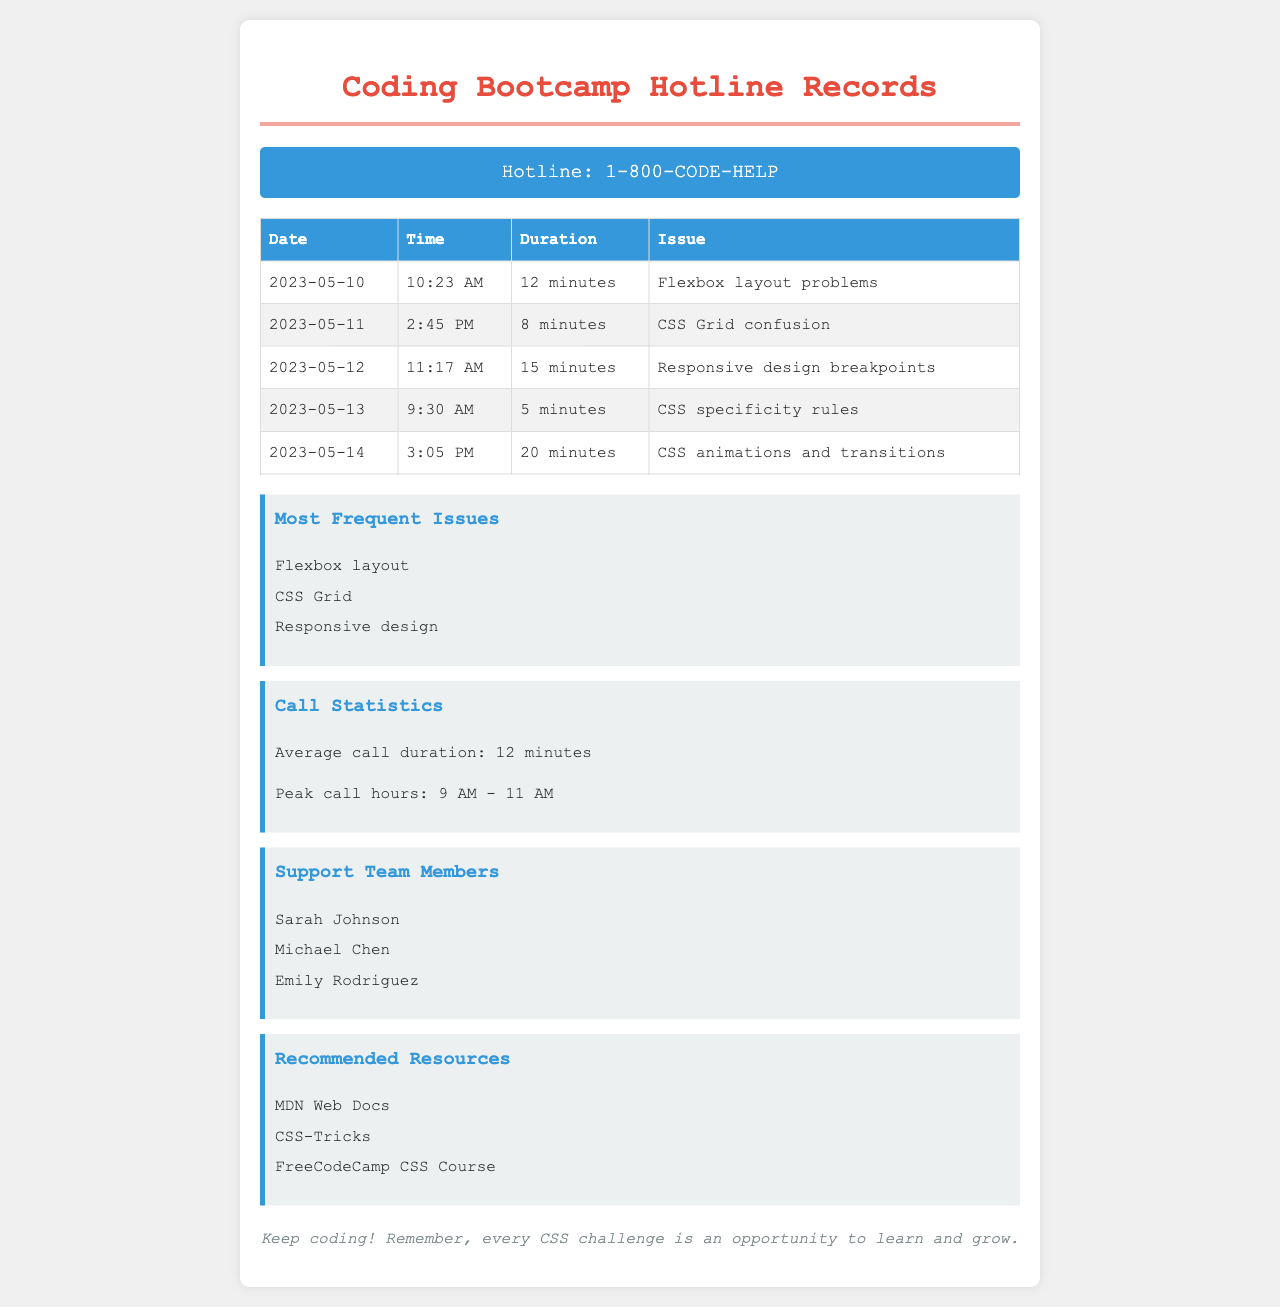what was the duration of the call on May 11? The duration of the call on May 11 is listed in the table, which shows 8 minutes.
Answer: 8 minutes who handled the issue about CSS animations? The support team members handling issues are listed, but no specific member is linked to the CSS animations call.
Answer: Not specified how many calls were made regarding Flexbox layout issues? The table indicates there was 1 call specifically regarding Flexbox layout problems.
Answer: 1 what is the average call duration? The average call duration is stated in the statistics section as 12 minutes.
Answer: 12 minutes which member of the support team is mentioned first? The member mentioned first in the support team section is Sarah Johnson.
Answer: Sarah Johnson what time did the call about CSS specificity occur? The call about CSS specificity rules occurred at 9:30 AM as per the table.
Answer: 9:30 AM how many minutes was the longest call? The longest call duration is found in the table and is 20 minutes.
Answer: 20 minutes what are the most frequent issues reported? The most frequent issues are listed in the info box; they include Flexbox layout, CSS Grid, and Responsive design.
Answer: Flexbox layout, CSS Grid, Responsive design when was the call regarding responsive design breakpoints? The call regarding responsive design breakpoints took place on May 12, as indicated in the table.
Answer: May 12 